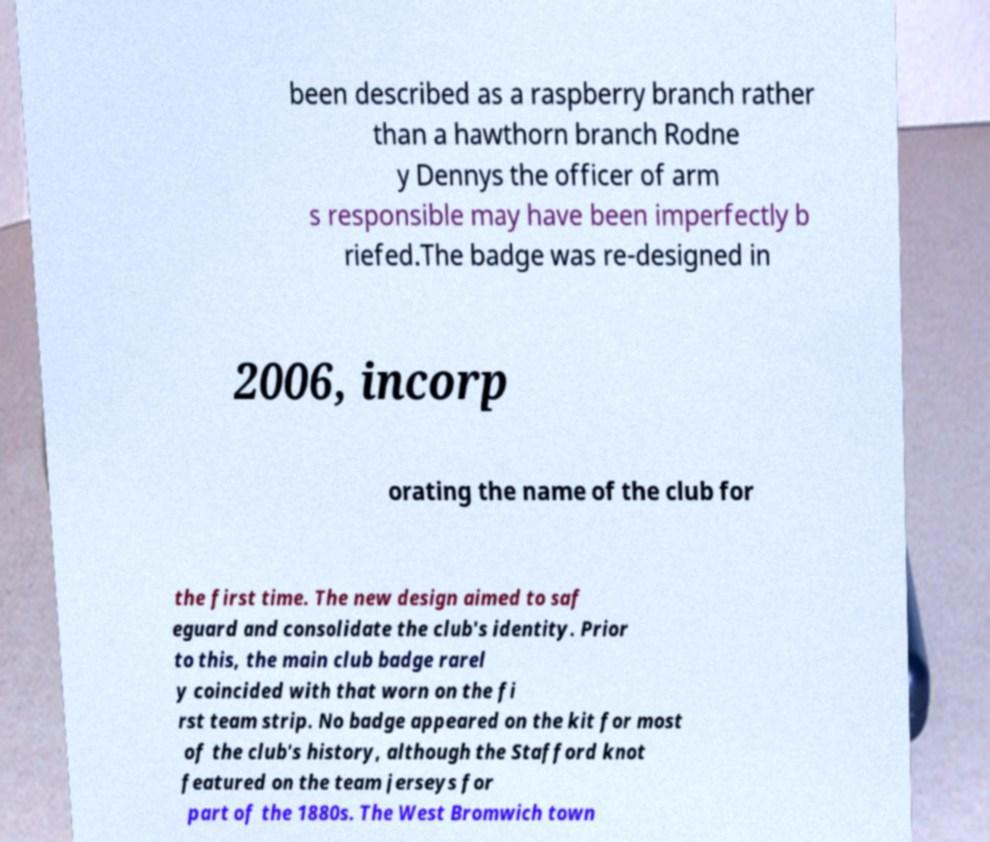Please identify and transcribe the text found in this image. been described as a raspberry branch rather than a hawthorn branch Rodne y Dennys the officer of arm s responsible may have been imperfectly b riefed.The badge was re-designed in 2006, incorp orating the name of the club for the first time. The new design aimed to saf eguard and consolidate the club's identity. Prior to this, the main club badge rarel y coincided with that worn on the fi rst team strip. No badge appeared on the kit for most of the club's history, although the Stafford knot featured on the team jerseys for part of the 1880s. The West Bromwich town 